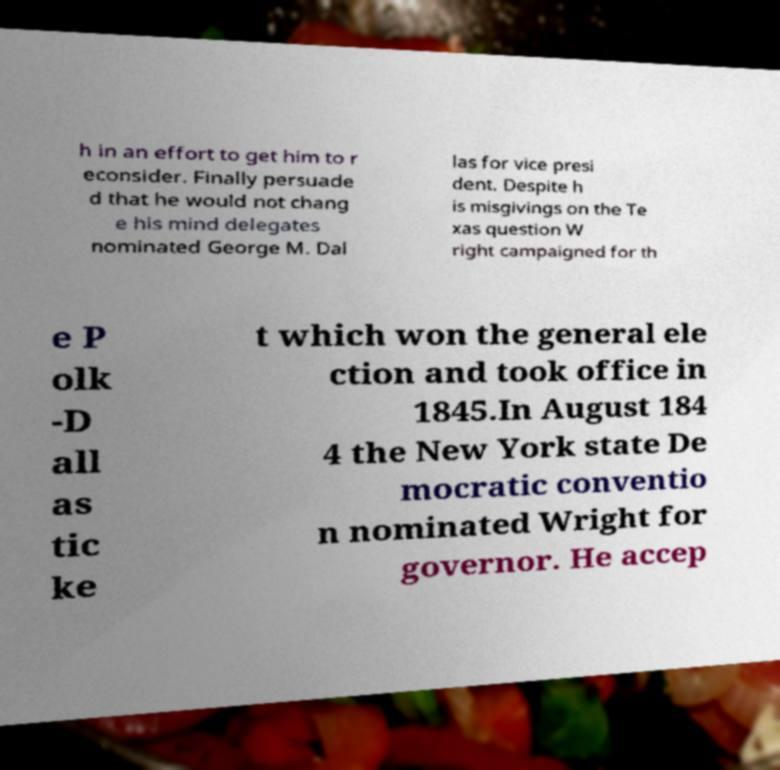I need the written content from this picture converted into text. Can you do that? h in an effort to get him to r econsider. Finally persuade d that he would not chang e his mind delegates nominated George M. Dal las for vice presi dent. Despite h is misgivings on the Te xas question W right campaigned for th e P olk -D all as tic ke t which won the general ele ction and took office in 1845.In August 184 4 the New York state De mocratic conventio n nominated Wright for governor. He accep 